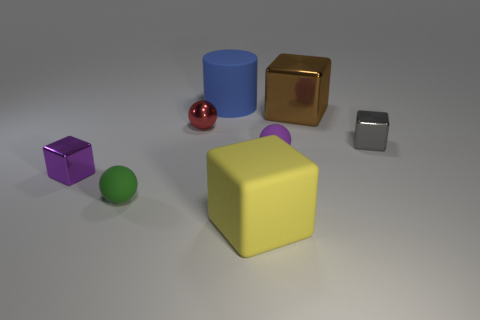Subtract all shiny blocks. How many blocks are left? 1 Subtract 1 gray blocks. How many objects are left? 7 Subtract all cylinders. How many objects are left? 7 Subtract 2 spheres. How many spheres are left? 1 Subtract all gray cubes. Subtract all cyan cylinders. How many cubes are left? 3 Subtract all yellow cylinders. How many brown cubes are left? 1 Subtract all small purple cubes. Subtract all green objects. How many objects are left? 6 Add 3 small things. How many small things are left? 8 Add 2 small purple spheres. How many small purple spheres exist? 3 Add 2 small brown metal balls. How many objects exist? 10 